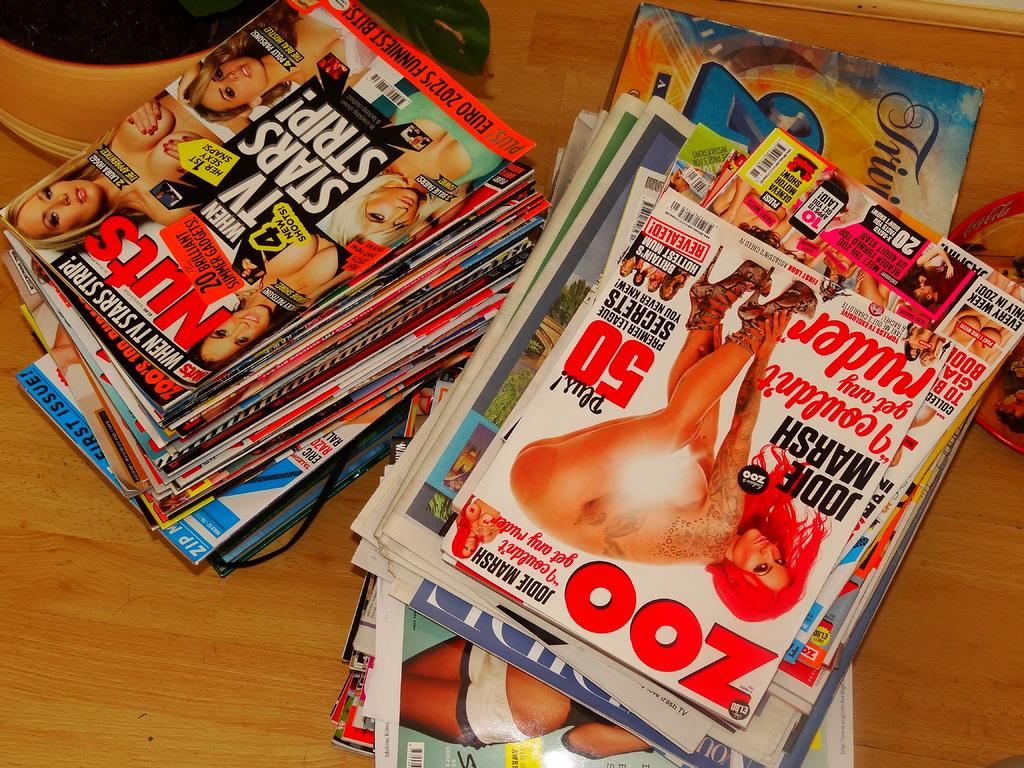<image>
Offer a succinct explanation of the picture presented. Two stacks of dirty magazines, including Zoo and Nuts, sitting on a table. 